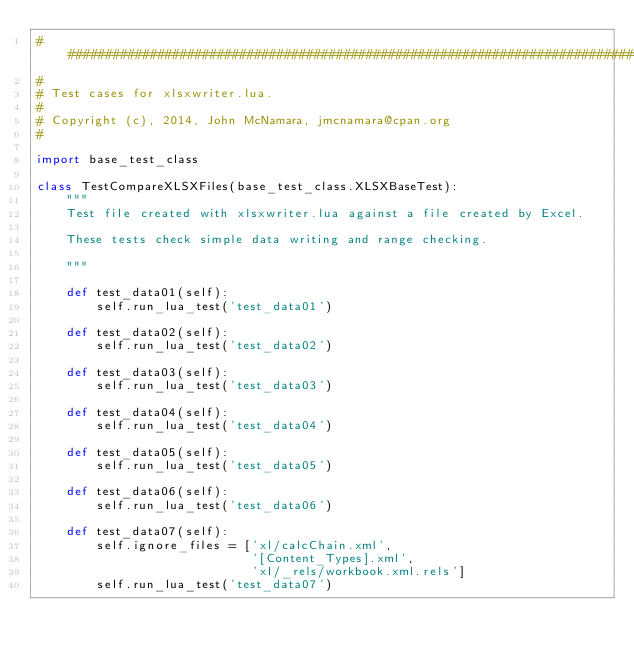Convert code to text. <code><loc_0><loc_0><loc_500><loc_500><_Python_>###############################################################################
#
# Test cases for xlsxwriter.lua.
#
# Copyright (c), 2014, John McNamara, jmcnamara@cpan.org
#

import base_test_class

class TestCompareXLSXFiles(base_test_class.XLSXBaseTest):
    """
    Test file created with xlsxwriter.lua against a file created by Excel.

    These tests check simple data writing and range checking.

    """

    def test_data01(self):
        self.run_lua_test('test_data01')

    def test_data02(self):
        self.run_lua_test('test_data02')

    def test_data03(self):
        self.run_lua_test('test_data03')

    def test_data04(self):
        self.run_lua_test('test_data04')

    def test_data05(self):
        self.run_lua_test('test_data05')

    def test_data06(self):
        self.run_lua_test('test_data06')

    def test_data07(self):
        self.ignore_files = ['xl/calcChain.xml',
                             '[Content_Types].xml',
                             'xl/_rels/workbook.xml.rels']
        self.run_lua_test('test_data07')
</code> 